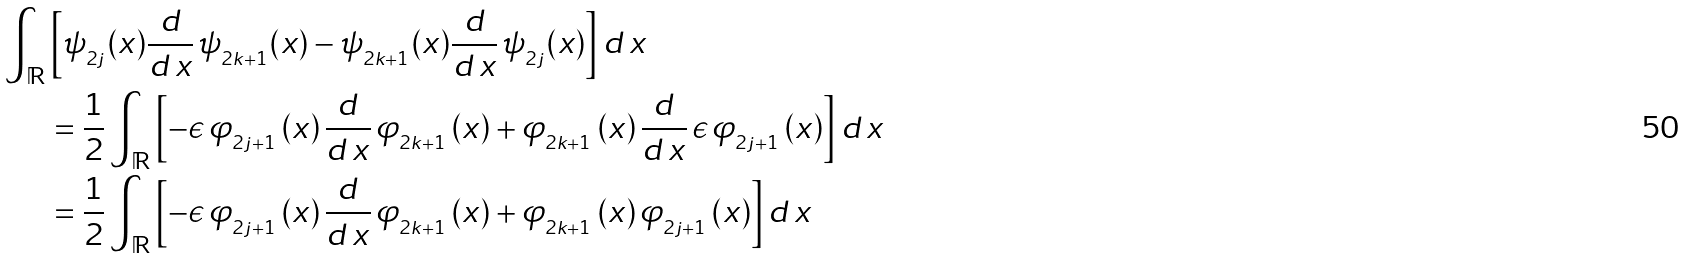<formula> <loc_0><loc_0><loc_500><loc_500>\int _ { \mathbb { R } } & \left [ \psi _ { _ { 2 j } } ( x ) \frac { d } { d \, x } \, \psi _ { _ { 2 k + 1 } } ( x ) - \psi _ { _ { 2 k + 1 } } ( x ) \frac { d } { d \, x } \, \psi _ { _ { 2 j } } ( x ) \right ] d \, x \\ & = \frac { 1 } { 2 } \int _ { \mathbb { R } } \left [ - \epsilon \, \varphi _ { _ { 2 j + 1 } } \left ( x \right ) \frac { d } { d \, x } \, \varphi _ { _ { 2 k + 1 } } \left ( x \right ) + \varphi _ { _ { 2 k + 1 } } \left ( x \right ) \frac { d } { d \, x } \, \epsilon \, \varphi _ { _ { 2 j + 1 } } \left ( x \right ) \right ] d \, x \\ & = \frac { 1 } { 2 } \int _ { \mathbb { R } } \left [ - \epsilon \, \varphi _ { _ { 2 j + 1 } } \left ( x \right ) \frac { d } { d \, x } \, \varphi _ { _ { 2 k + 1 } } \left ( x \right ) + \varphi _ { _ { 2 k + 1 } } \left ( x \right ) \varphi _ { _ { 2 j + 1 } } \left ( x \right ) \right ] d \, x \\</formula> 